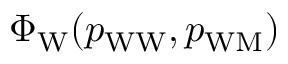Convert formula to latex. <formula><loc_0><loc_0><loc_500><loc_500>\Phi _ { W } ( p _ { W W } , p _ { W M } )</formula> 